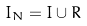<formula> <loc_0><loc_0><loc_500><loc_500>I _ { N } = I \cup R</formula> 